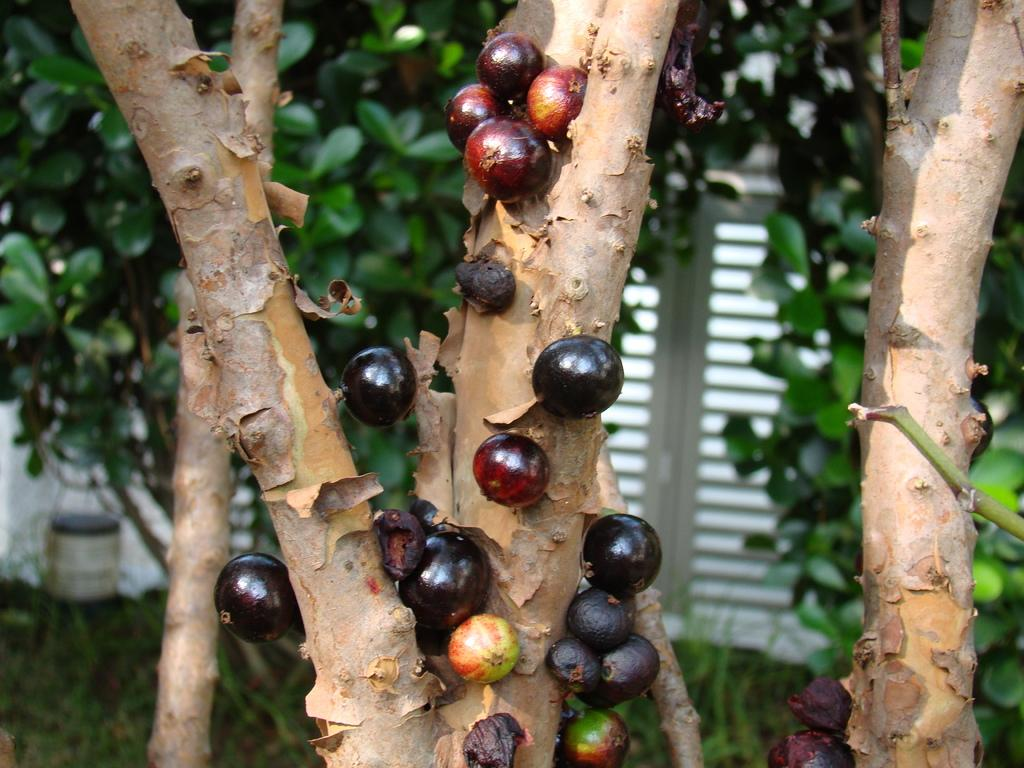What color are the fruits on the tree stems in the image? The fruits on the tree stems are black in color. What can be seen in the background of the image? There are trees with leaves and a window visible in the background. What type of government is depicted in the image? There is no depiction of a government in the image; it features black color fruits on tree stems and trees with leaves in the background. 